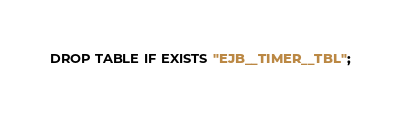<code> <loc_0><loc_0><loc_500><loc_500><_SQL_>DROP TABLE IF EXISTS "EJB__TIMER__TBL";</code> 